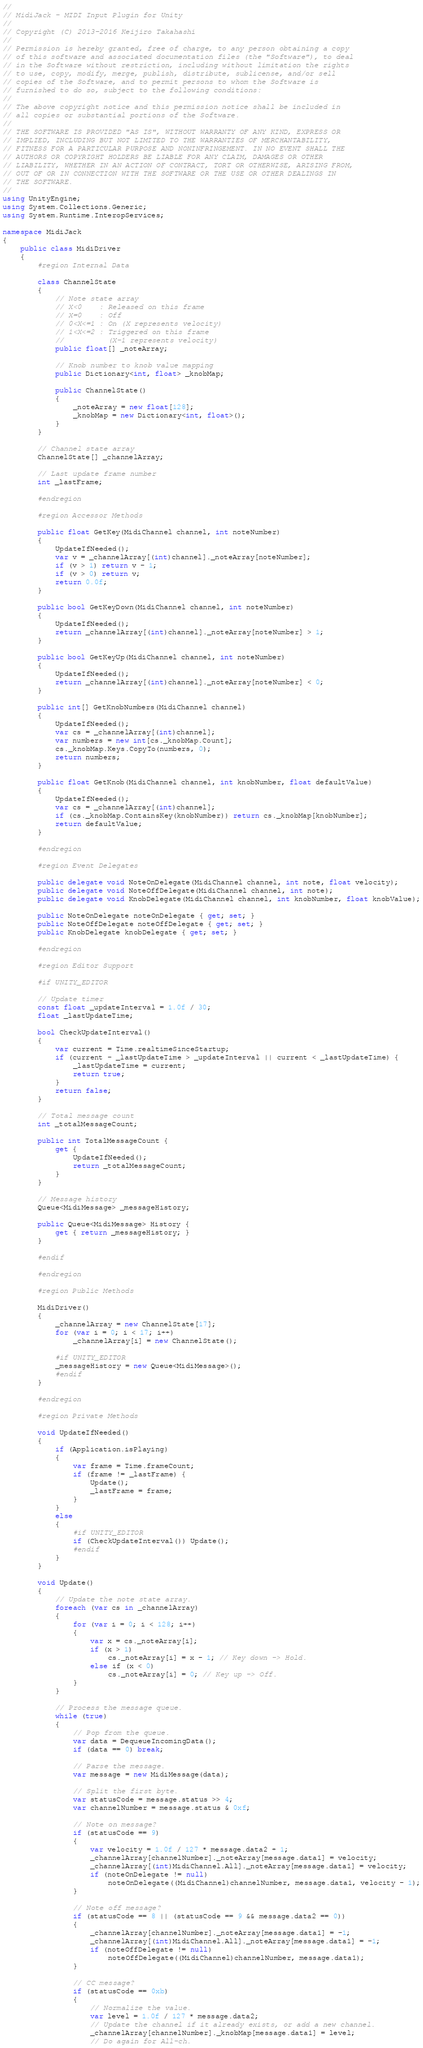<code> <loc_0><loc_0><loc_500><loc_500><_C#_>//
// MidiJack - MIDI Input Plugin for Unity
//
// Copyright (C) 2013-2016 Keijiro Takahashi
//
// Permission is hereby granted, free of charge, to any person obtaining a copy
// of this software and associated documentation files (the "Software"), to deal
// in the Software without restriction, including without limitation the rights
// to use, copy, modify, merge, publish, distribute, sublicense, and/or sell
// copies of the Software, and to permit persons to whom the Software is
// furnished to do so, subject to the following conditions:
//
// The above copyright notice and this permission notice shall be included in
// all copies or substantial portions of the Software.
//
// THE SOFTWARE IS PROVIDED "AS IS", WITHOUT WARRANTY OF ANY KIND, EXPRESS OR
// IMPLIED, INCLUDING BUT NOT LIMITED TO THE WARRANTIES OF MERCHANTABILITY,
// FITNESS FOR A PARTICULAR PURPOSE AND NONINFRINGEMENT. IN NO EVENT SHALL THE
// AUTHORS OR COPYRIGHT HOLDERS BE LIABLE FOR ANY CLAIM, DAMAGES OR OTHER
// LIABILITY, WHETHER IN AN ACTION OF CONTRACT, TORT OR OTHERWISE, ARISING FROM,
// OUT OF OR IN CONNECTION WITH THE SOFTWARE OR THE USE OR OTHER DEALINGS IN
// THE SOFTWARE.
//
using UnityEngine;
using System.Collections.Generic;
using System.Runtime.InteropServices;

namespace MidiJack
{
    public class MidiDriver
    {
        #region Internal Data

        class ChannelState
        {
            // Note state array
            // X<0    : Released on this frame
            // X=0    : Off
            // 0<X<=1 : On (X represents velocity)
            // 1<X<=2 : Triggered on this frame
            //          (X-1 represents velocity)
            public float[] _noteArray;

            // Knob number to knob value mapping
            public Dictionary<int, float> _knobMap;

            public ChannelState()
            {
                _noteArray = new float[128];
                _knobMap = new Dictionary<int, float>();
            }
        }

        // Channel state array
        ChannelState[] _channelArray;

        // Last update frame number
        int _lastFrame;

        #endregion

        #region Accessor Methods

        public float GetKey(MidiChannel channel, int noteNumber)
        {
            UpdateIfNeeded();
            var v = _channelArray[(int)channel]._noteArray[noteNumber];
            if (v > 1) return v - 1;
            if (v > 0) return v;
            return 0.0f;
        }

        public bool GetKeyDown(MidiChannel channel, int noteNumber)
        {
            UpdateIfNeeded();
            return _channelArray[(int)channel]._noteArray[noteNumber] > 1;
        }

        public bool GetKeyUp(MidiChannel channel, int noteNumber)
        {
            UpdateIfNeeded();
            return _channelArray[(int)channel]._noteArray[noteNumber] < 0;
        }

        public int[] GetKnobNumbers(MidiChannel channel)
        {
            UpdateIfNeeded();
            var cs = _channelArray[(int)channel];
            var numbers = new int[cs._knobMap.Count];
            cs._knobMap.Keys.CopyTo(numbers, 0);
            return numbers;
        }

        public float GetKnob(MidiChannel channel, int knobNumber, float defaultValue)
        {
            UpdateIfNeeded();
            var cs = _channelArray[(int)channel];
            if (cs._knobMap.ContainsKey(knobNumber)) return cs._knobMap[knobNumber];
            return defaultValue;
        }

        #endregion

        #region Event Delegates

        public delegate void NoteOnDelegate(MidiChannel channel, int note, float velocity);
        public delegate void NoteOffDelegate(MidiChannel channel, int note);
        public delegate void KnobDelegate(MidiChannel channel, int knobNumber, float knobValue);

        public NoteOnDelegate noteOnDelegate { get; set; }
        public NoteOffDelegate noteOffDelegate { get; set; }
        public KnobDelegate knobDelegate { get; set; }

        #endregion

        #region Editor Support

        #if UNITY_EDITOR

        // Update timer
        const float _updateInterval = 1.0f / 30;
        float _lastUpdateTime;

        bool CheckUpdateInterval()
        {
            var current = Time.realtimeSinceStartup;
            if (current - _lastUpdateTime > _updateInterval || current < _lastUpdateTime) {
                _lastUpdateTime = current;
                return true;
            }
            return false;
        }

        // Total message count
        int _totalMessageCount;

        public int TotalMessageCount {
            get {
                UpdateIfNeeded();
                return _totalMessageCount;
            }
        }

        // Message history
        Queue<MidiMessage> _messageHistory;

        public Queue<MidiMessage> History {
            get { return _messageHistory; }
        }

        #endif

        #endregion

        #region Public Methods

        MidiDriver()
        {
            _channelArray = new ChannelState[17];
            for (var i = 0; i < 17; i++)
                _channelArray[i] = new ChannelState();

            #if UNITY_EDITOR
            _messageHistory = new Queue<MidiMessage>();
            #endif
        }

        #endregion

        #region Private Methods

        void UpdateIfNeeded()
        {
            if (Application.isPlaying)
            {
                var frame = Time.frameCount;
                if (frame != _lastFrame) {
                    Update();
                    _lastFrame = frame;
                }
            }
            else
            {
                #if UNITY_EDITOR
                if (CheckUpdateInterval()) Update();
                #endif
            }
        }

        void Update()
        {
            // Update the note state array.
            foreach (var cs in _channelArray)
            {
                for (var i = 0; i < 128; i++)
                {
                    var x = cs._noteArray[i];
                    if (x > 1)
                        cs._noteArray[i] = x - 1; // Key down -> Hold.
                    else if (x < 0)
                        cs._noteArray[i] = 0; // Key up -> Off.
                }
            }

            // Process the message queue.
            while (true)
            {
                // Pop from the queue.
                var data = DequeueIncomingData();
                if (data == 0) break;

                // Parse the message.
                var message = new MidiMessage(data);

                // Split the first byte.
                var statusCode = message.status >> 4;
                var channelNumber = message.status & 0xf;

                // Note on message?
                if (statusCode == 9)
                {
                    var velocity = 1.0f / 127 * message.data2 + 1;
                    _channelArray[channelNumber]._noteArray[message.data1] = velocity;
                    _channelArray[(int)MidiChannel.All]._noteArray[message.data1] = velocity;
                    if (noteOnDelegate != null)
                        noteOnDelegate((MidiChannel)channelNumber, message.data1, velocity - 1);
                }

                // Note off message?
                if (statusCode == 8 || (statusCode == 9 && message.data2 == 0))
                {
                    _channelArray[channelNumber]._noteArray[message.data1] = -1;
                    _channelArray[(int)MidiChannel.All]._noteArray[message.data1] = -1;
                    if (noteOffDelegate != null)
                        noteOffDelegate((MidiChannel)channelNumber, message.data1);
                }

                // CC message?
                if (statusCode == 0xb)
                {
                    // Normalize the value.
                    var level = 1.0f / 127 * message.data2;
                    // Update the channel if it already exists, or add a new channel.
                    _channelArray[channelNumber]._knobMap[message.data1] = level;
                    // Do again for All-ch.</code> 